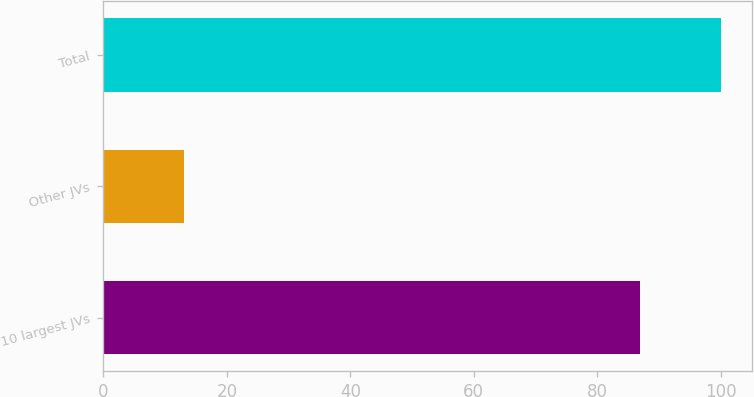Convert chart to OTSL. <chart><loc_0><loc_0><loc_500><loc_500><bar_chart><fcel>10 largest JVs<fcel>Other JVs<fcel>Total<nl><fcel>87<fcel>13<fcel>100<nl></chart> 